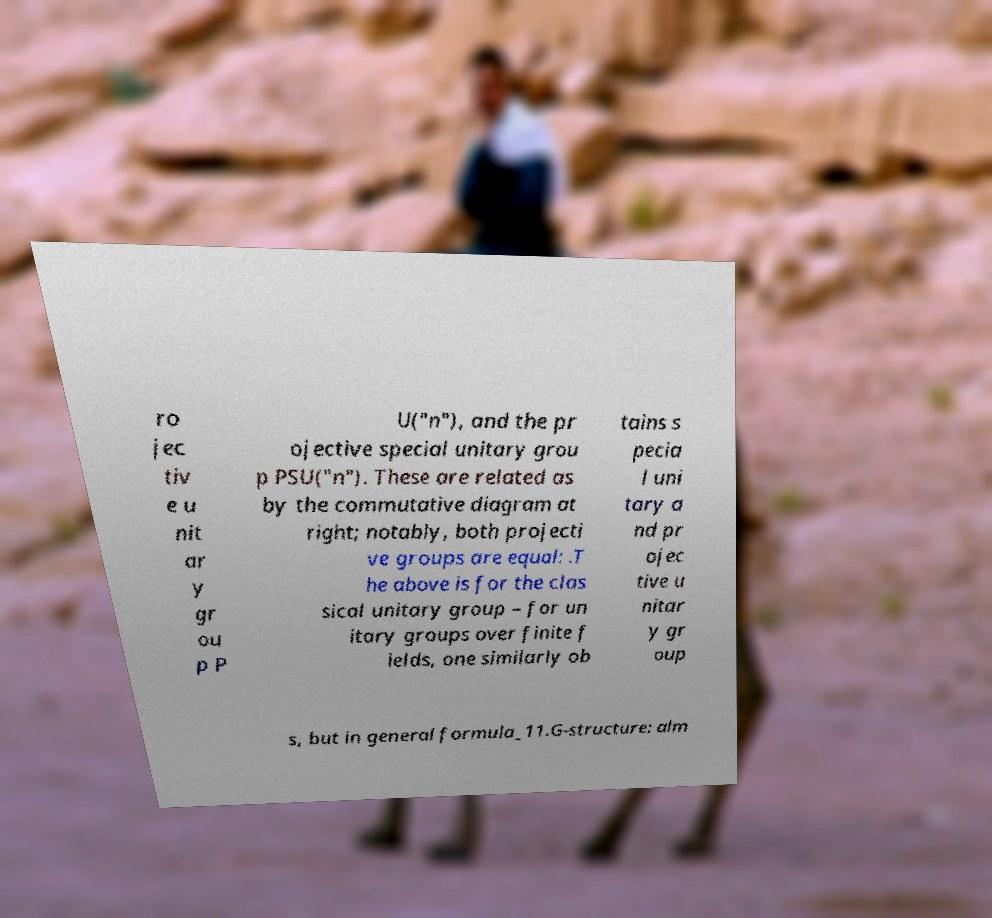For documentation purposes, I need the text within this image transcribed. Could you provide that? ro jec tiv e u nit ar y gr ou p P U("n"), and the pr ojective special unitary grou p PSU("n"). These are related as by the commutative diagram at right; notably, both projecti ve groups are equal: .T he above is for the clas sical unitary group – for un itary groups over finite f ields, one similarly ob tains s pecia l uni tary a nd pr ojec tive u nitar y gr oup s, but in general formula_11.G-structure: alm 